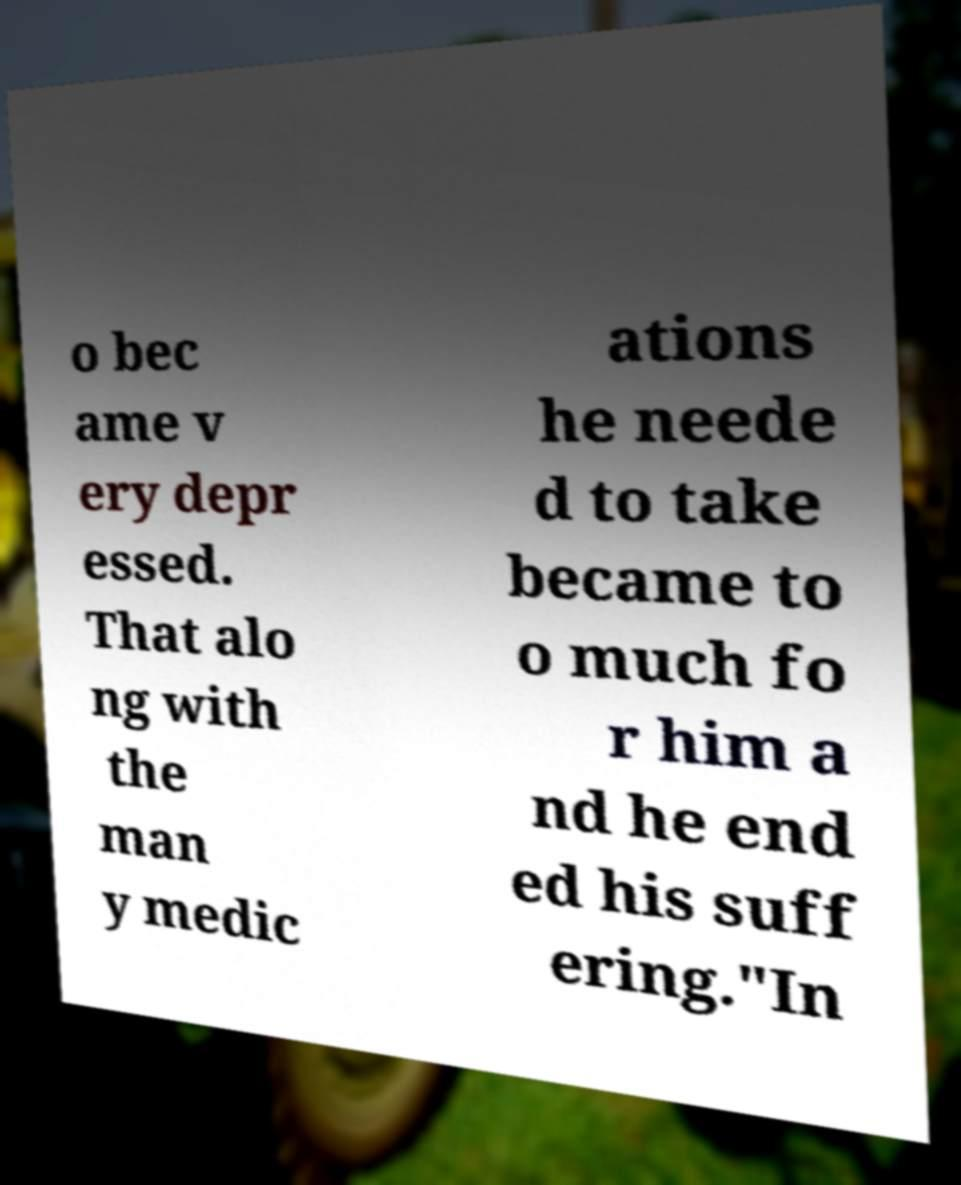For documentation purposes, I need the text within this image transcribed. Could you provide that? o bec ame v ery depr essed. That alo ng with the man y medic ations he neede d to take became to o much fo r him a nd he end ed his suff ering."In 